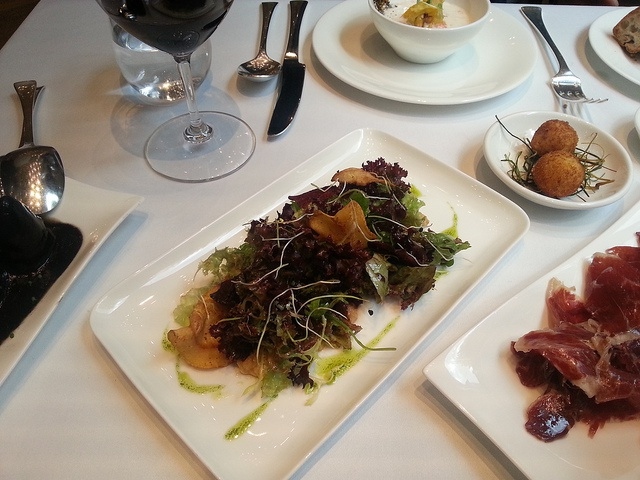Describe the objects in this image and their specific colors. I can see dining table in darkgray, lightgray, black, and tan tones, bowl in black, lightgray, darkgray, brown, and maroon tones, wine glass in black, darkgray, and gray tones, bowl in black, darkgray, lightgray, and tan tones, and spoon in black, gray, and white tones in this image. 